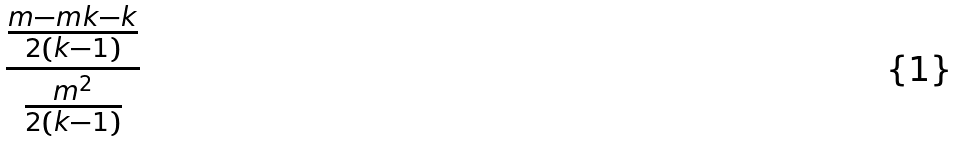<formula> <loc_0><loc_0><loc_500><loc_500>\frac { \frac { m - m k - k } { 2 ( k - 1 ) } } { \frac { m ^ { 2 } } { 2 ( k - 1 ) } }</formula> 